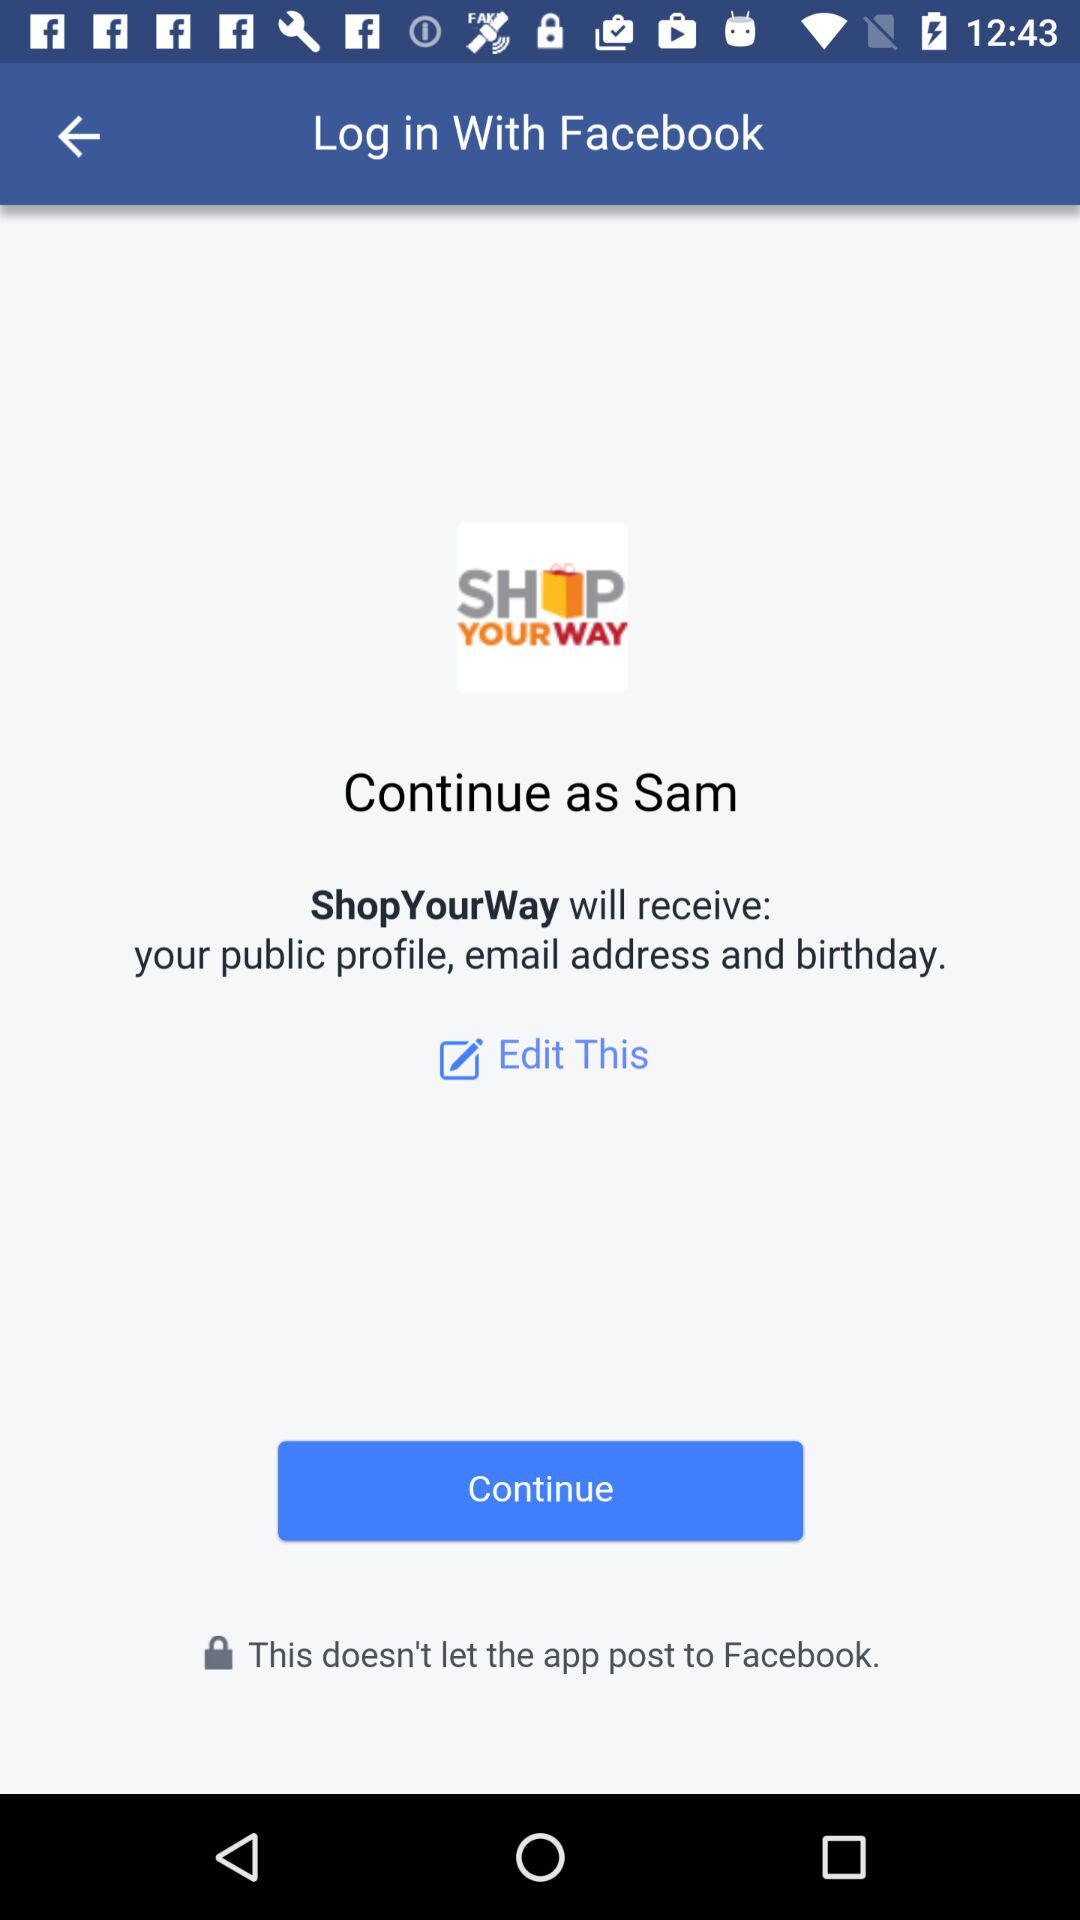What is the login name? The login name is Sam. 